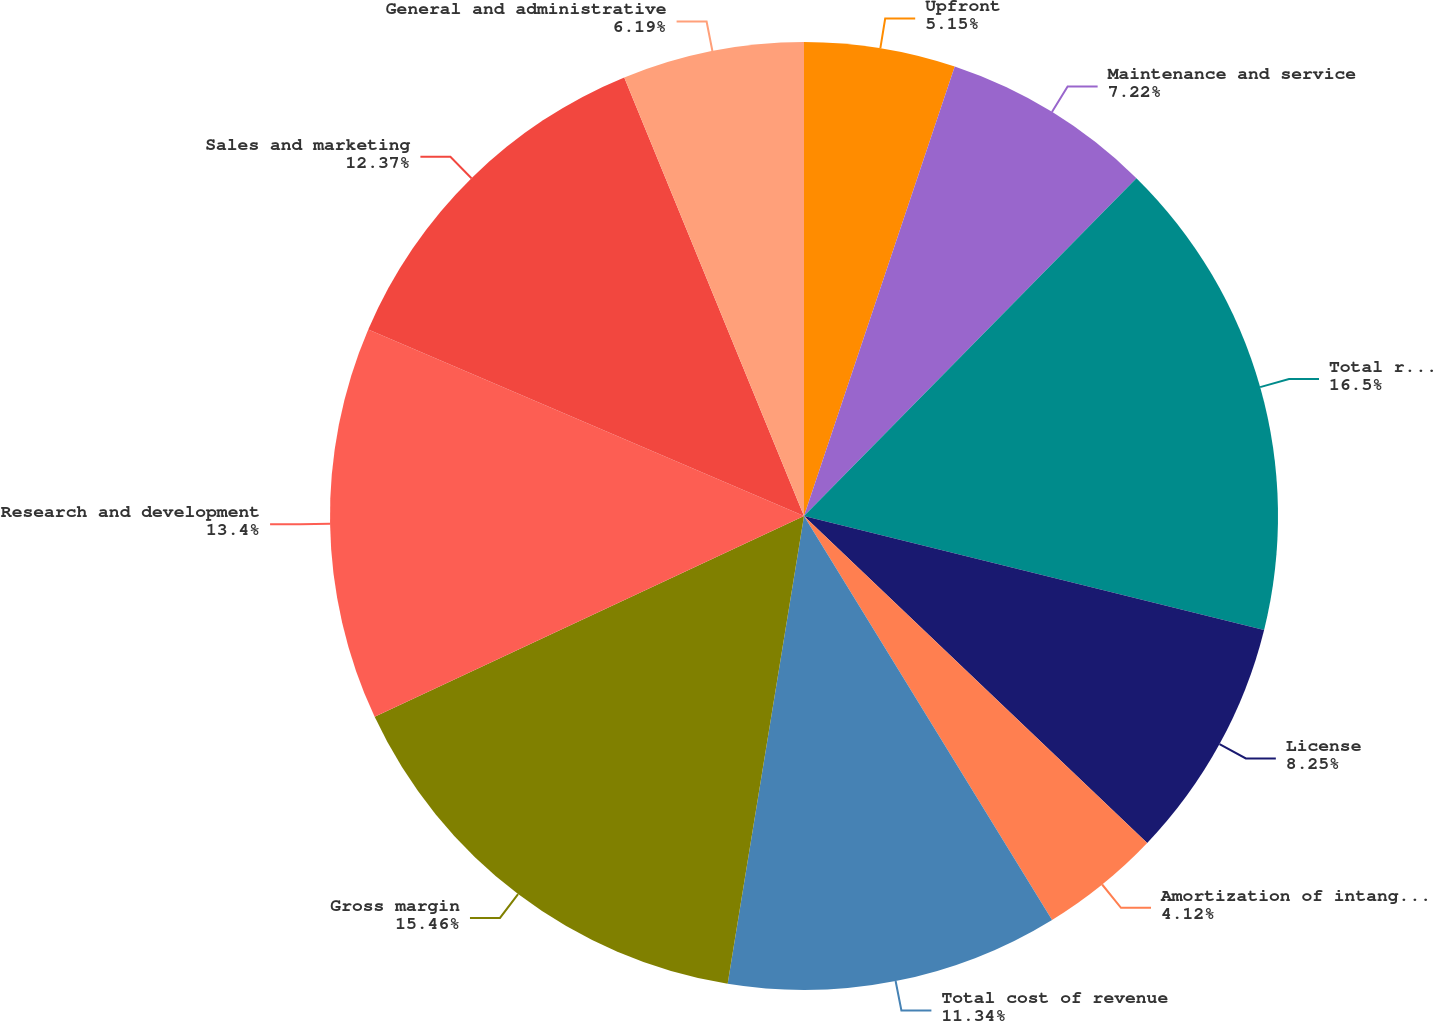<chart> <loc_0><loc_0><loc_500><loc_500><pie_chart><fcel>Upfront<fcel>Maintenance and service<fcel>Total revenue<fcel>License<fcel>Amortization of intangible<fcel>Total cost of revenue<fcel>Gross margin<fcel>Research and development<fcel>Sales and marketing<fcel>General and administrative<nl><fcel>5.15%<fcel>7.22%<fcel>16.49%<fcel>8.25%<fcel>4.12%<fcel>11.34%<fcel>15.46%<fcel>13.4%<fcel>12.37%<fcel>6.19%<nl></chart> 